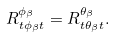Convert formula to latex. <formula><loc_0><loc_0><loc_500><loc_500>R ^ { \phi _ { \beta } } _ { t { \phi _ { \beta } } t } = R ^ { \theta _ { \beta } } _ { t { \theta _ { \beta } } t } .</formula> 